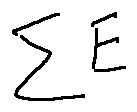<formula> <loc_0><loc_0><loc_500><loc_500>\sum E</formula> 